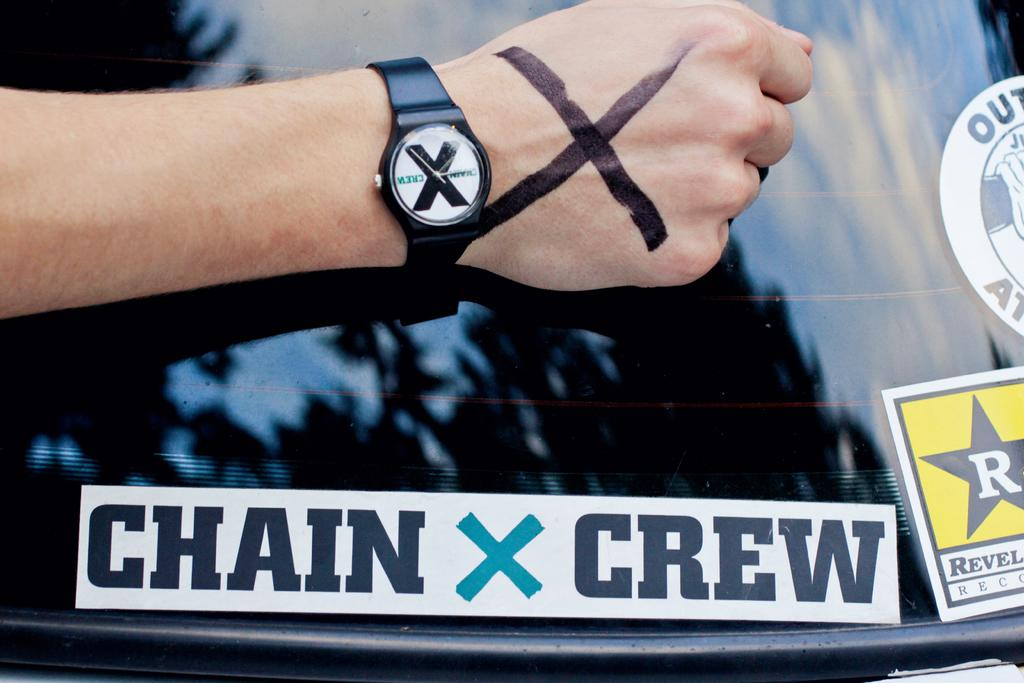Provide a one-sentence caption for the provided image. Person wearing a watch placing their arm above a "Chain X Crew" sticker. 